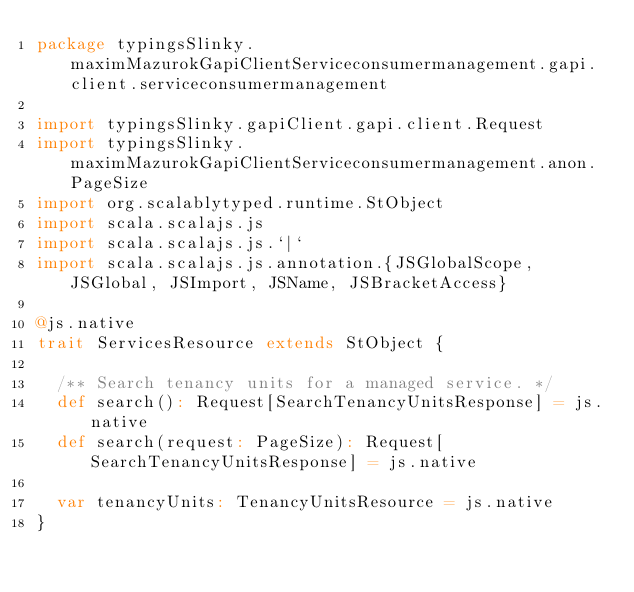<code> <loc_0><loc_0><loc_500><loc_500><_Scala_>package typingsSlinky.maximMazurokGapiClientServiceconsumermanagement.gapi.client.serviceconsumermanagement

import typingsSlinky.gapiClient.gapi.client.Request
import typingsSlinky.maximMazurokGapiClientServiceconsumermanagement.anon.PageSize
import org.scalablytyped.runtime.StObject
import scala.scalajs.js
import scala.scalajs.js.`|`
import scala.scalajs.js.annotation.{JSGlobalScope, JSGlobal, JSImport, JSName, JSBracketAccess}

@js.native
trait ServicesResource extends StObject {
  
  /** Search tenancy units for a managed service. */
  def search(): Request[SearchTenancyUnitsResponse] = js.native
  def search(request: PageSize): Request[SearchTenancyUnitsResponse] = js.native
  
  var tenancyUnits: TenancyUnitsResource = js.native
}
</code> 